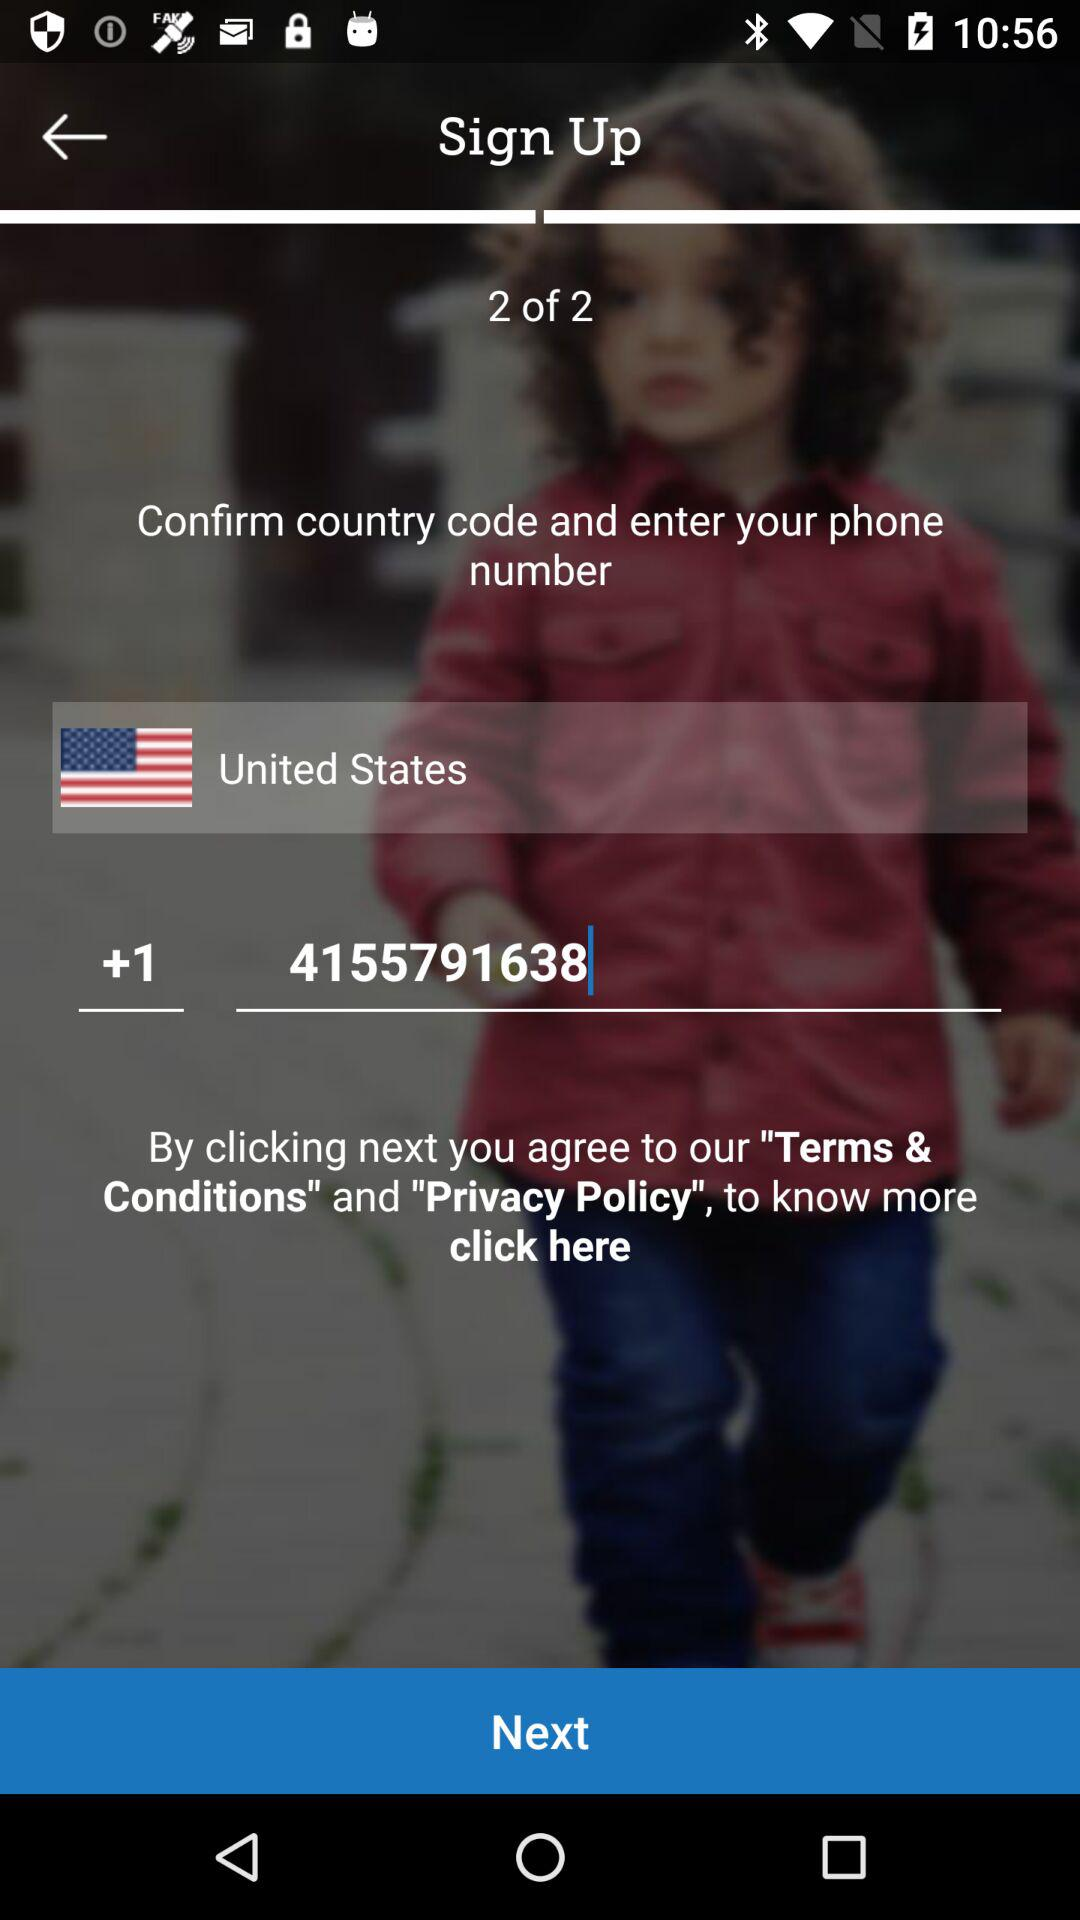What county has been chosen? The chosen country is the United States. 